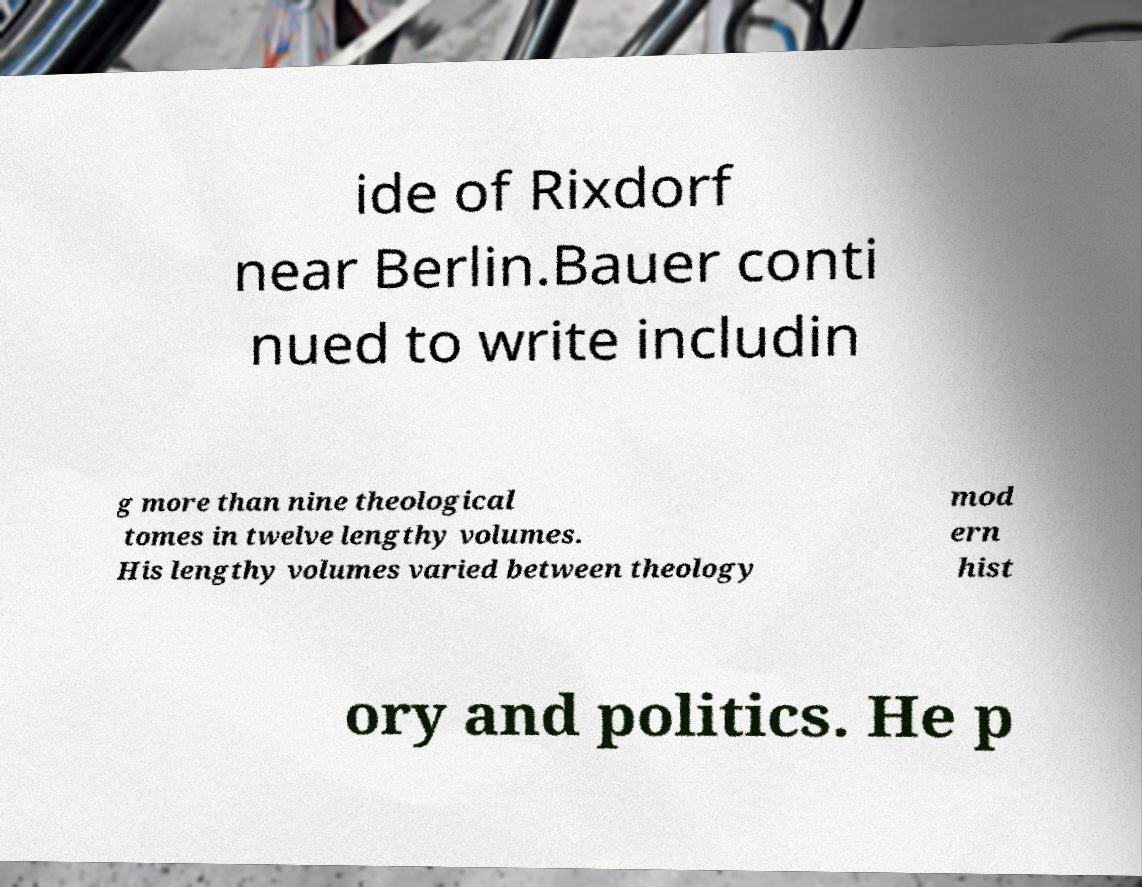What messages or text are displayed in this image? I need them in a readable, typed format. ide of Rixdorf near Berlin.Bauer conti nued to write includin g more than nine theological tomes in twelve lengthy volumes. His lengthy volumes varied between theology mod ern hist ory and politics. He p 